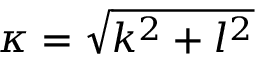Convert formula to latex. <formula><loc_0><loc_0><loc_500><loc_500>\kappa = \sqrt { k ^ { 2 } + l ^ { 2 } }</formula> 